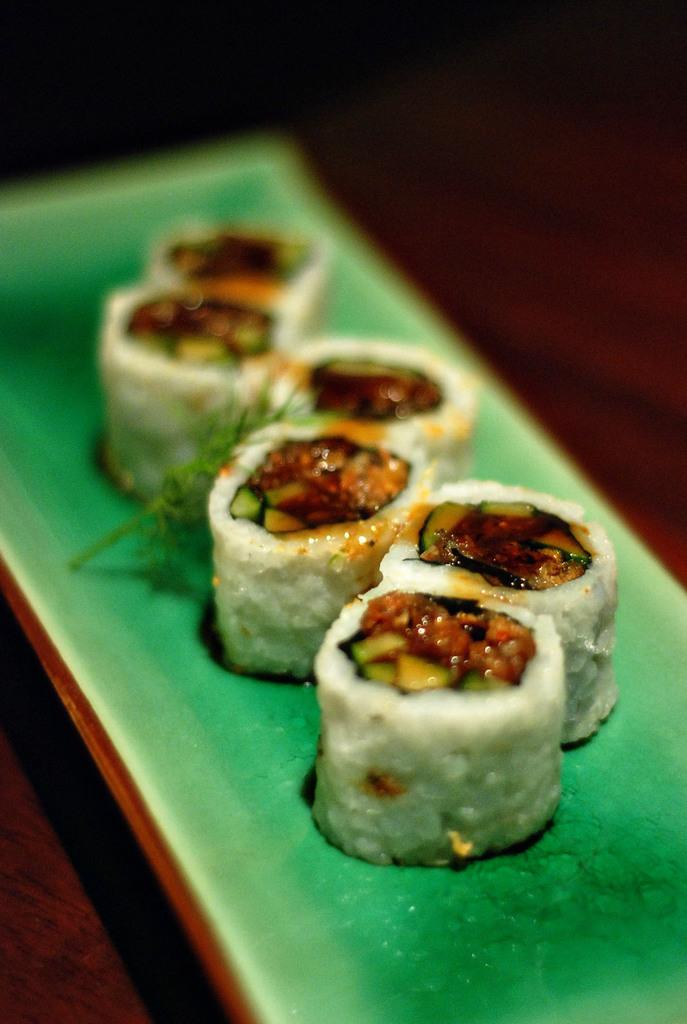What is on the plate in the image? There is a food item on a plate in the image. What type of behavior can be observed from the grape in the image? There is no grape present in the image, and therefore no behavior can be observed. 